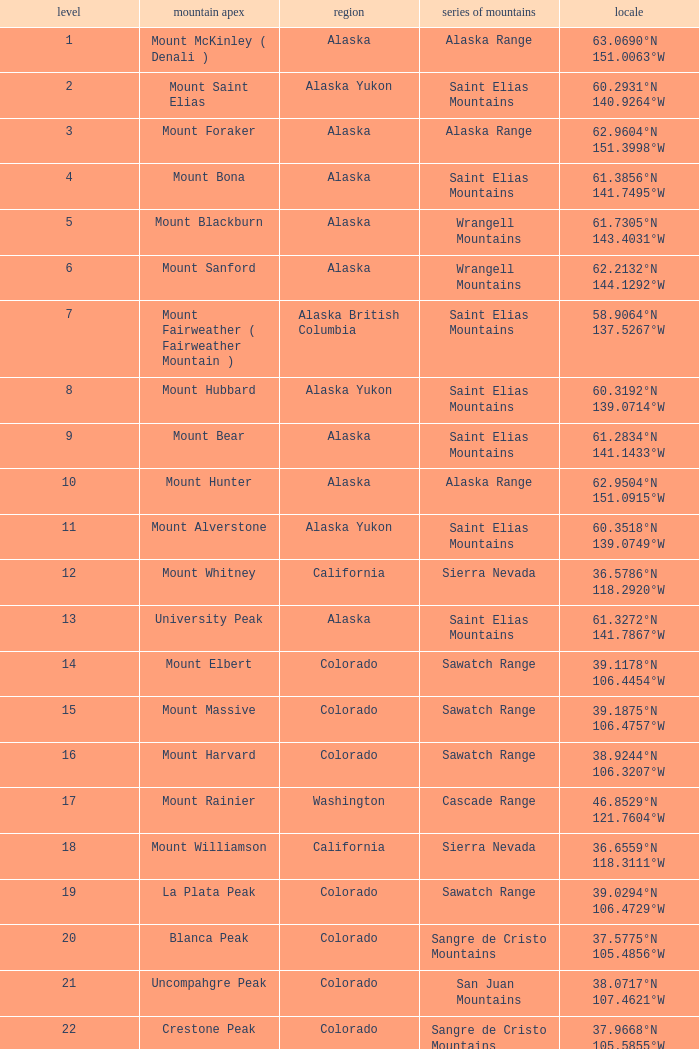What is the mountain peak when the location is 37.5775°n 105.4856°w? Blanca Peak. 